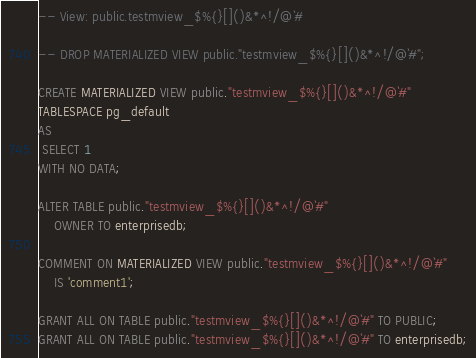Convert code to text. <code><loc_0><loc_0><loc_500><loc_500><_SQL_>-- View: public.testmview_$%{}[]()&*^!/@`#

-- DROP MATERIALIZED VIEW public."testmview_$%{}[]()&*^!/@`#";

CREATE MATERIALIZED VIEW public."testmview_$%{}[]()&*^!/@`#"
TABLESPACE pg_default
AS
 SELECT 1
WITH NO DATA;

ALTER TABLE public."testmview_$%{}[]()&*^!/@`#"
    OWNER TO enterprisedb;

COMMENT ON MATERIALIZED VIEW public."testmview_$%{}[]()&*^!/@`#"
    IS 'comment1';

GRANT ALL ON TABLE public."testmview_$%{}[]()&*^!/@`#" TO PUBLIC;
GRANT ALL ON TABLE public."testmview_$%{}[]()&*^!/@`#" TO enterprisedb;
</code> 